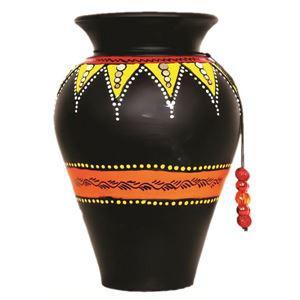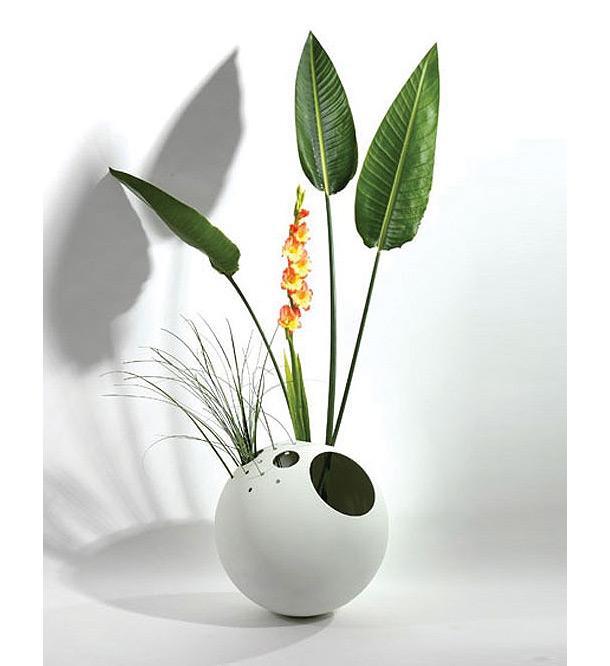The first image is the image on the left, the second image is the image on the right. Given the left and right images, does the statement "there is a vase with at least one tulip in it" hold true? Answer yes or no. No. The first image is the image on the left, the second image is the image on the right. Considering the images on both sides, is "The right image contains at least two flower vases." valid? Answer yes or no. No. 